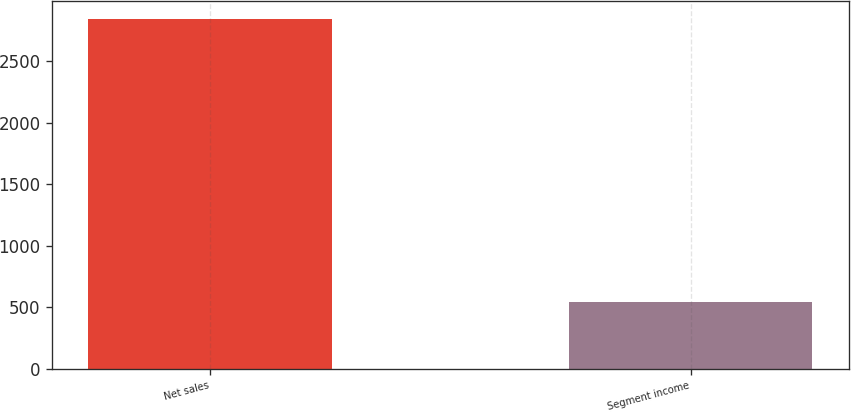<chart> <loc_0><loc_0><loc_500><loc_500><bar_chart><fcel>Net sales<fcel>Segment income<nl><fcel>2844.4<fcel>546<nl></chart> 